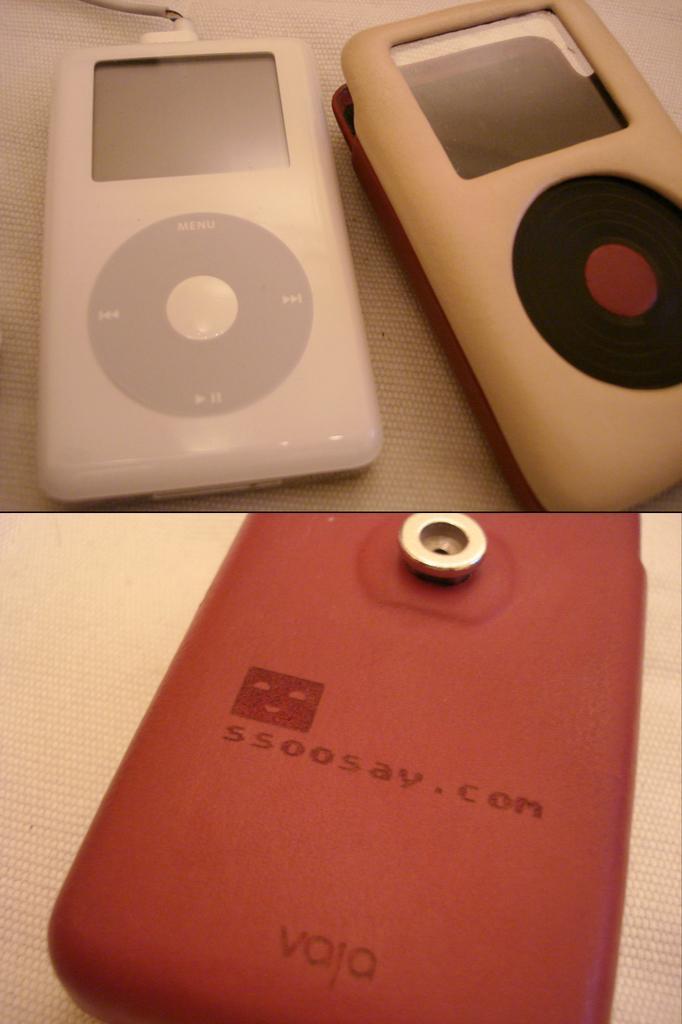Could you give a brief overview of what you see in this image? This image consists of airpods kept on the desk. 